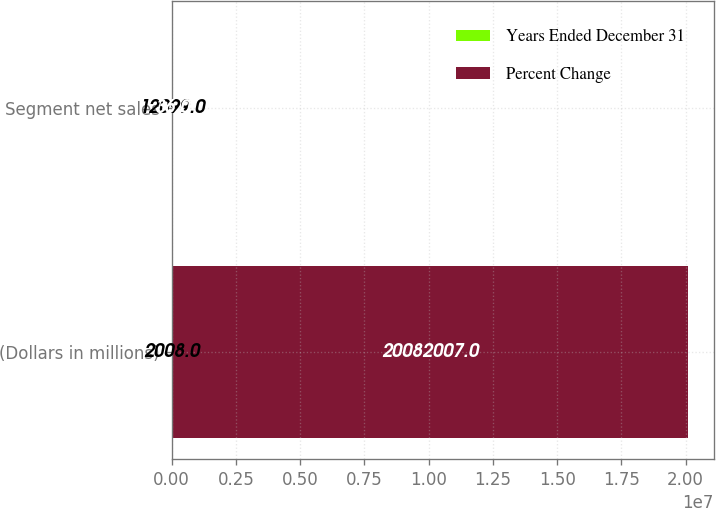<chart> <loc_0><loc_0><loc_500><loc_500><stacked_bar_chart><ecel><fcel>(Dollars in millions)<fcel>Segment net sales<nl><fcel>Years Ended December 31<fcel>2008<fcel>12099<nl><fcel>Percent Change<fcel>2.0082e+07<fcel>36<nl></chart> 